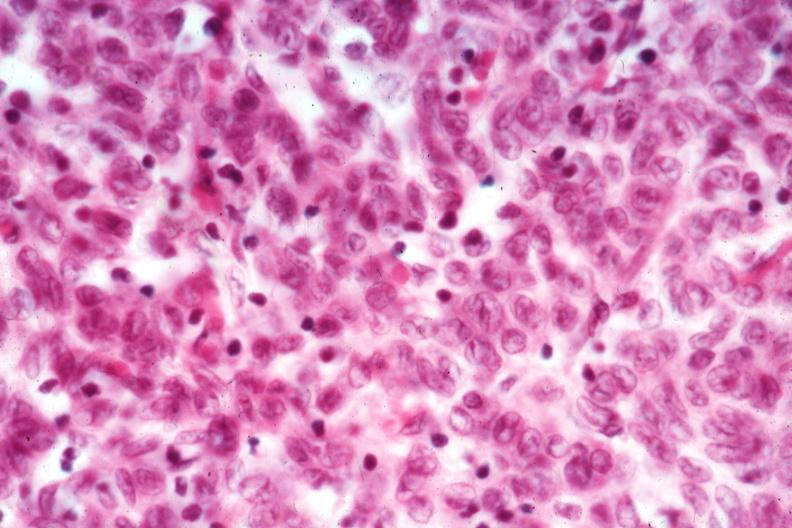what is present?
Answer the question using a single word or phrase. Thymus 